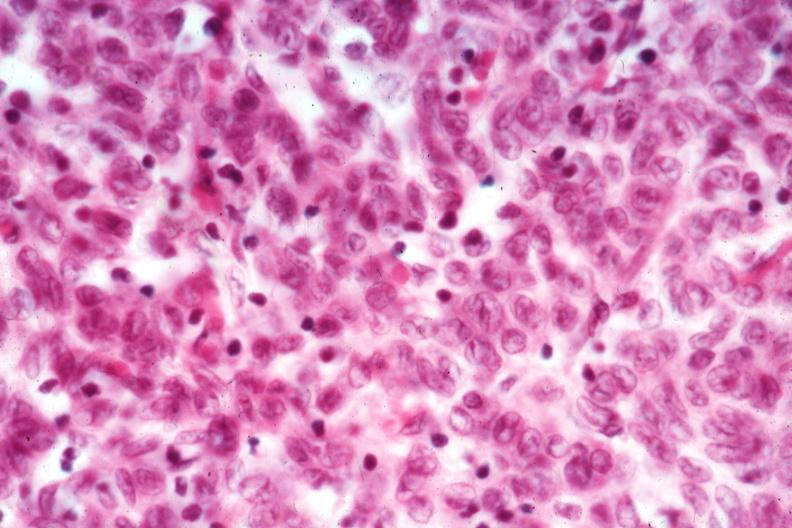what is present?
Answer the question using a single word or phrase. Thymus 